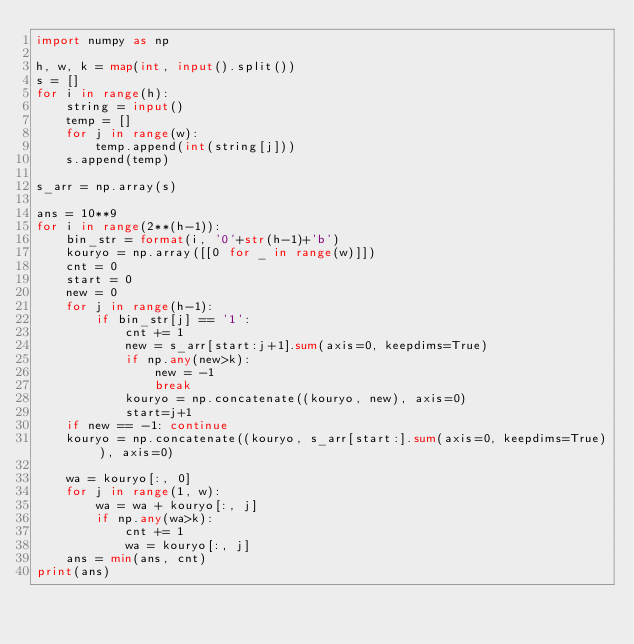Convert code to text. <code><loc_0><loc_0><loc_500><loc_500><_Python_>import numpy as np

h, w, k = map(int, input().split())
s = []
for i in range(h):
    string = input()
    temp = []
    for j in range(w):
        temp.append(int(string[j]))
    s.append(temp)

s_arr = np.array(s)

ans = 10**9
for i in range(2**(h-1)):
    bin_str = format(i, '0'+str(h-1)+'b')
    kouryo = np.array([[0 for _ in range(w)]])
    cnt = 0
    start = 0
    new = 0
    for j in range(h-1):
        if bin_str[j] == '1':
            cnt += 1
            new = s_arr[start:j+1].sum(axis=0, keepdims=True)
            if np.any(new>k):
                new = -1
                break
            kouryo = np.concatenate((kouryo, new), axis=0)
            start=j+1
    if new == -1: continue
    kouryo = np.concatenate((kouryo, s_arr[start:].sum(axis=0, keepdims=True)), axis=0)

    wa = kouryo[:, 0]
    for j in range(1, w):
        wa = wa + kouryo[:, j]
        if np.any(wa>k):
            cnt += 1
            wa = kouryo[:, j]
    ans = min(ans, cnt)
print(ans)</code> 